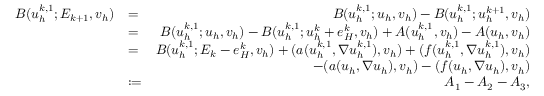Convert formula to latex. <formula><loc_0><loc_0><loc_500><loc_500>\begin{array} { r l r } { B ( u _ { h } ^ { k , 1 } ; E _ { k + 1 } , v _ { h } ) } & { = } & { B ( u _ { h } ^ { k , 1 } ; u _ { h } , v _ { h } ) - B ( u _ { h } ^ { k , 1 } ; u _ { h } ^ { k + 1 } , v _ { h } ) } \\ & { = } & { B ( u _ { h } ^ { k , 1 } ; u _ { h } , v _ { h } ) - B ( u _ { h } ^ { k , 1 } ; u _ { h } ^ { k } + e _ { H } ^ { k } , v _ { h } ) + A ( u _ { h } ^ { k , 1 } , v _ { h } ) - A ( u _ { h } , v _ { h } ) } \\ & { = } & { B ( u _ { h } ^ { k , 1 } ; E _ { k } - e _ { H } ^ { k } , v _ { h } ) + ( a ( u _ { h } ^ { k , 1 } , \nabla u _ { h } ^ { k , 1 } ) , v _ { h } ) + ( f ( u _ { h } ^ { k , 1 } , \nabla u _ { h } ^ { k , 1 } ) , v _ { h } ) } \\ & { - ( a ( u _ { h } , \nabla u _ { h } ) , v _ { h } ) - ( f ( u _ { h } , \nabla u _ { h } ) , v _ { h } ) } \\ & { \colon = } & { A _ { 1 } - A _ { 2 } - A _ { 3 } , } \end{array}</formula> 